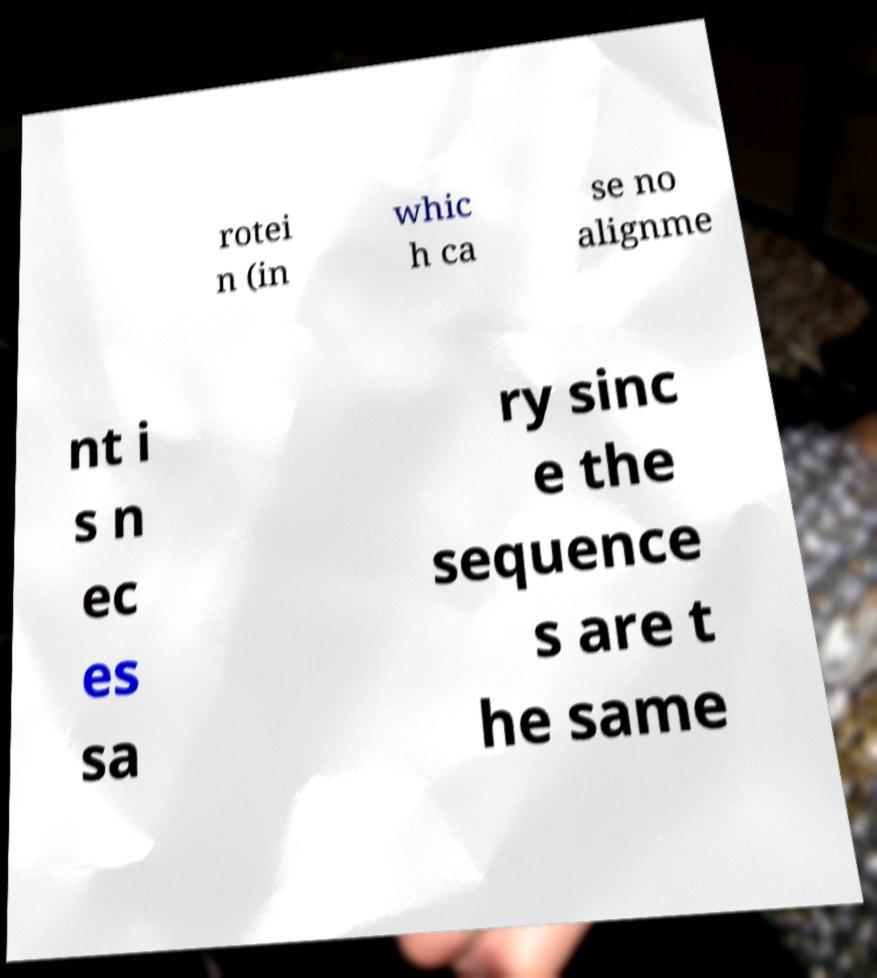Please read and relay the text visible in this image. What does it say? rotei n (in whic h ca se no alignme nt i s n ec es sa ry sinc e the sequence s are t he same 